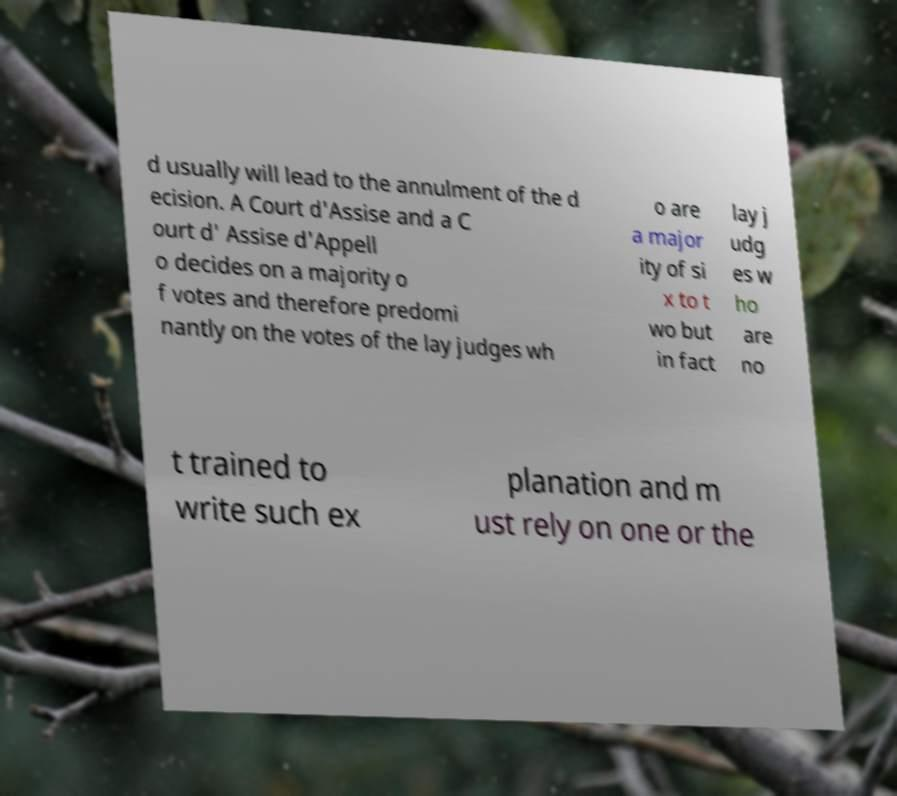For documentation purposes, I need the text within this image transcribed. Could you provide that? d usually will lead to the annulment of the d ecision. A Court d'Assise and a C ourt d' Assise d'Appell o decides on a majority o f votes and therefore predomi nantly on the votes of the lay judges wh o are a major ity of si x to t wo but in fact lay j udg es w ho are no t trained to write such ex planation and m ust rely on one or the 